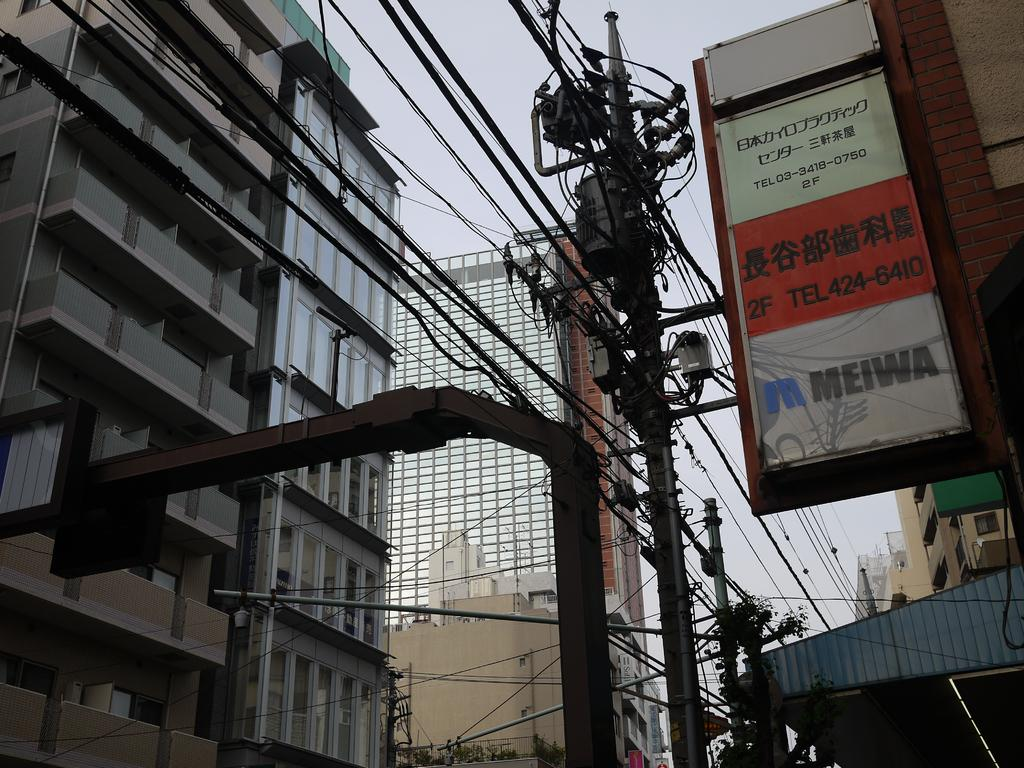What type of structures can be seen in the image? There are buildings in the image. What are the current poles used for? Current poles are present in the image, likely for supporting wires. What else can be seen connected to the current poles? Wires are visible in the image, connected to the current poles. What type of vegetation is present in the image? Trees are in the image. What type of signage or advertisements might be present on the boards? Boards are present in the image, which could be used for signage or advertisements. What is the color of the sky in the image? The sky appears to be white in color. How many cacti are visible in the image? There are no cacti present in the image. What level of experience does the beginner have in the image? There is no indication of a beginner or any experience level in the image. 